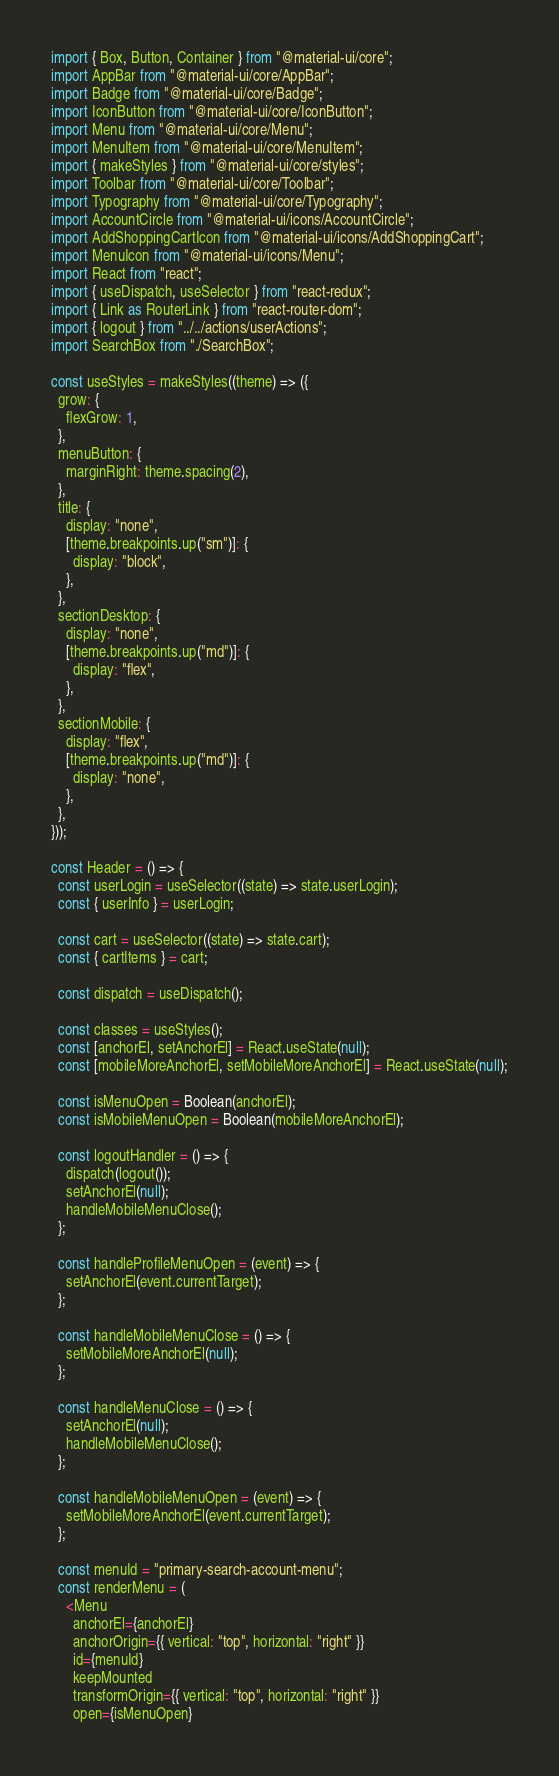Convert code to text. <code><loc_0><loc_0><loc_500><loc_500><_JavaScript_>import { Box, Button, Container } from "@material-ui/core";
import AppBar from "@material-ui/core/AppBar";
import Badge from "@material-ui/core/Badge";
import IconButton from "@material-ui/core/IconButton";
import Menu from "@material-ui/core/Menu";
import MenuItem from "@material-ui/core/MenuItem";
import { makeStyles } from "@material-ui/core/styles";
import Toolbar from "@material-ui/core/Toolbar";
import Typography from "@material-ui/core/Typography";
import AccountCircle from "@material-ui/icons/AccountCircle";
import AddShoppingCartIcon from "@material-ui/icons/AddShoppingCart";
import MenuIcon from "@material-ui/icons/Menu";
import React from "react";
import { useDispatch, useSelector } from "react-redux";
import { Link as RouterLink } from "react-router-dom";
import { logout } from "../../actions/userActions";
import SearchBox from "./SearchBox";

const useStyles = makeStyles((theme) => ({
  grow: {
    flexGrow: 1,
  },
  menuButton: {
    marginRight: theme.spacing(2),
  },
  title: {
    display: "none",
    [theme.breakpoints.up("sm")]: {
      display: "block",
    },
  },
  sectionDesktop: {
    display: "none",
    [theme.breakpoints.up("md")]: {
      display: "flex",
    },
  },
  sectionMobile: {
    display: "flex",
    [theme.breakpoints.up("md")]: {
      display: "none",
    },
  },
}));

const Header = () => {
  const userLogin = useSelector((state) => state.userLogin);
  const { userInfo } = userLogin;

  const cart = useSelector((state) => state.cart);
  const { cartItems } = cart;

  const dispatch = useDispatch();

  const classes = useStyles();
  const [anchorEl, setAnchorEl] = React.useState(null);
  const [mobileMoreAnchorEl, setMobileMoreAnchorEl] = React.useState(null);

  const isMenuOpen = Boolean(anchorEl);
  const isMobileMenuOpen = Boolean(mobileMoreAnchorEl);

  const logoutHandler = () => {
    dispatch(logout());
    setAnchorEl(null);
    handleMobileMenuClose();
  };

  const handleProfileMenuOpen = (event) => {
    setAnchorEl(event.currentTarget);
  };

  const handleMobileMenuClose = () => {
    setMobileMoreAnchorEl(null);
  };

  const handleMenuClose = () => {
    setAnchorEl(null);
    handleMobileMenuClose();
  };

  const handleMobileMenuOpen = (event) => {
    setMobileMoreAnchorEl(event.currentTarget);
  };

  const menuId = "primary-search-account-menu";
  const renderMenu = (
    <Menu
      anchorEl={anchorEl}
      anchorOrigin={{ vertical: "top", horizontal: "right" }}
      id={menuId}
      keepMounted
      transformOrigin={{ vertical: "top", horizontal: "right" }}
      open={isMenuOpen}</code> 